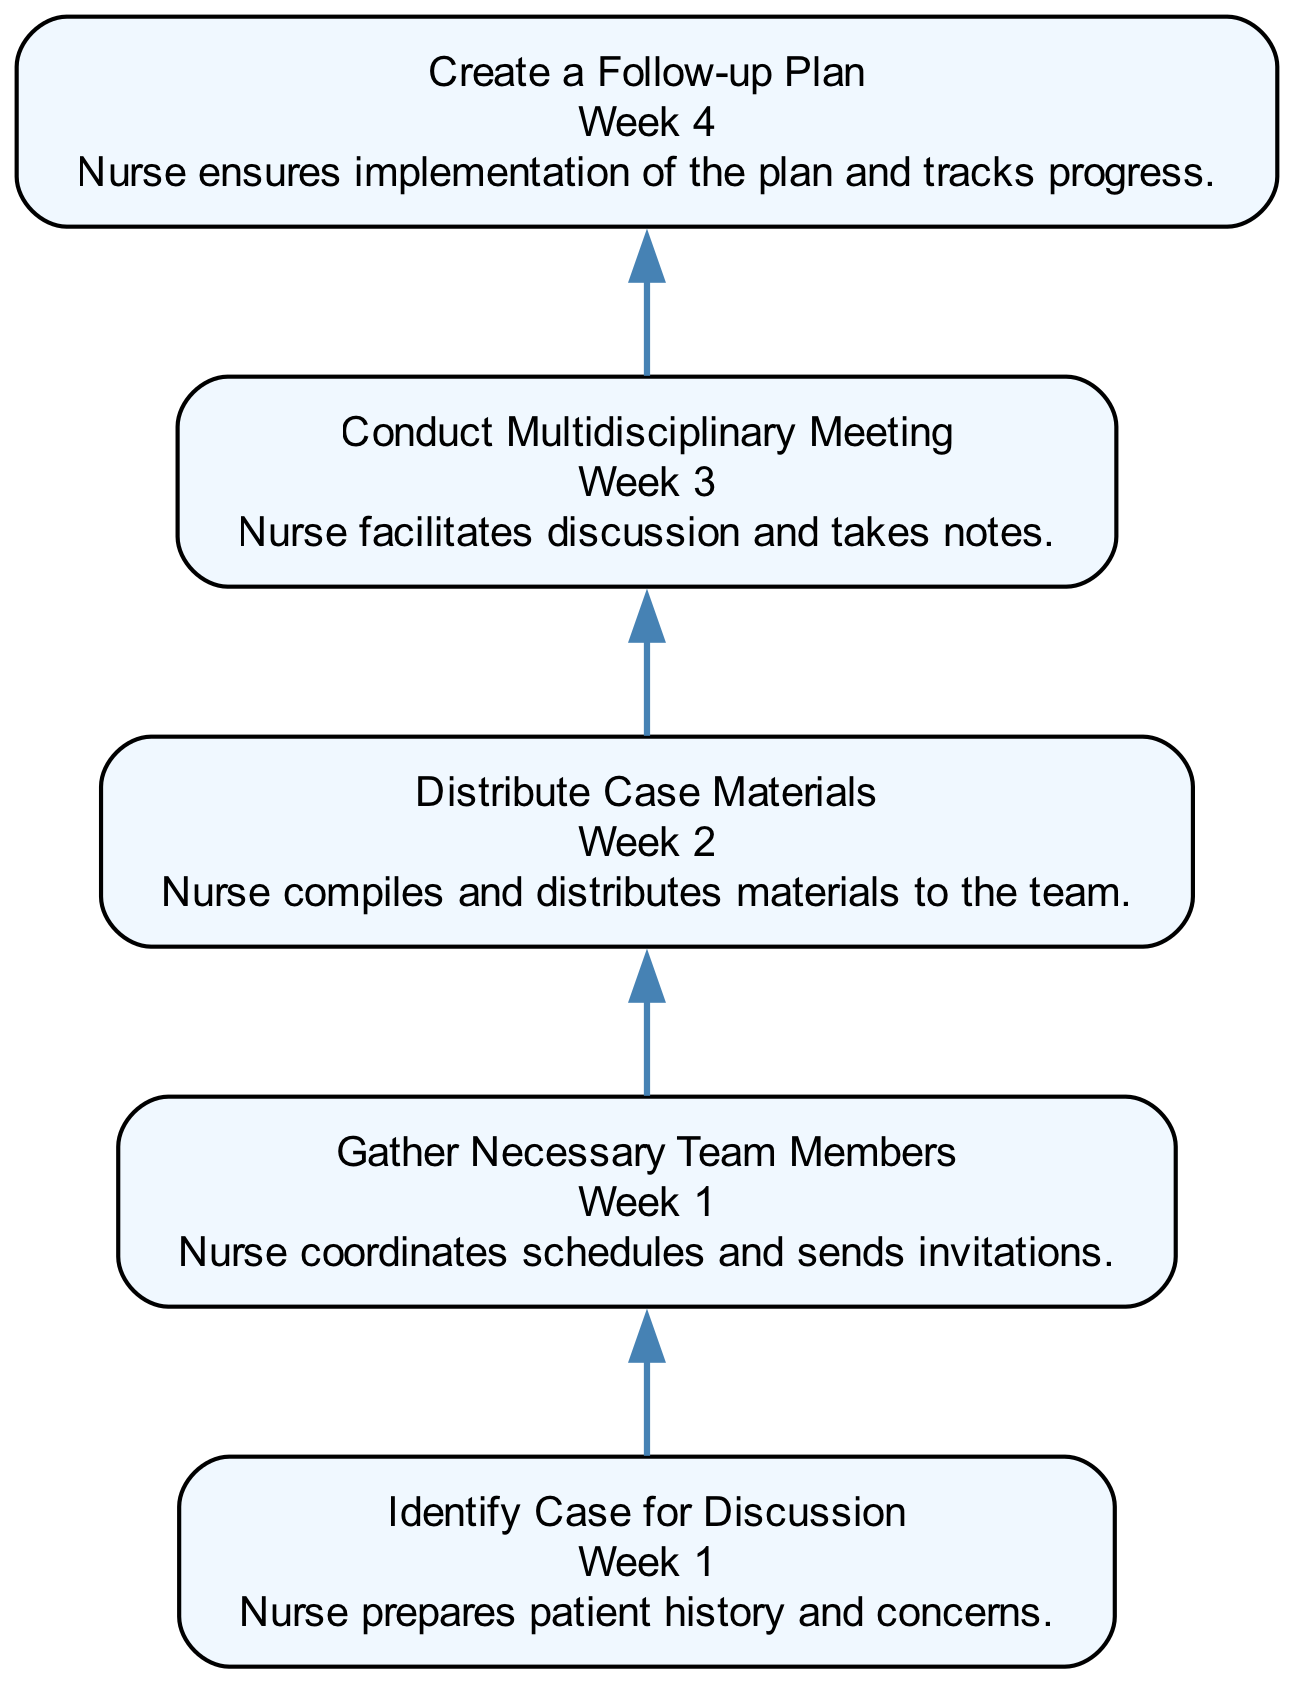What is the first step in the flow chart? The first step is to "Identify Case for Discussion," as this is the initial node in the flow chart sequence.
Answer: Identify Case for Discussion What is the timeline for distributing case materials? The second node in the diagram lists the timeline for distributing case materials as "Week 2."
Answer: Week 2 How many total steps are in the flow chart? By counting each of the distinct nodes in the flow chart, there are five total steps outlining the process.
Answer: 5 What participant contribution is made during the "Conduct Multidisciplinary Meeting"? According to the information in that specific node, the participant contribution listed is "Nurse facilitates discussion and takes notes."
Answer: Nurse facilitates discussion and takes notes Which step follows "Gather Necessary Team Members"? By following the directional flow from the second node, the step that immediately follows is "Distribute Case Materials."
Answer: Distribute Case Materials What is the timeline for creating a follow-up plan? The node for the follow-up plan states that the timeline for this step is "Week 4," indicating when this task should be executed.
Answer: Week 4 What is the last participant contribution mentioned in the diagram? The final participant contribution listed in the diagram corresponds to the last step, which is "Nurse ensures implementation of the plan and tracks progress."
Answer: Nurse ensures implementation of the plan and tracks progress What is the relationship between "Identify Case for Discussion" and "Conduct Multidisciplinary Meeting"? The first node leads directly to the fourth node, indicating that identifying a case is a prerequisite for conducting the meeting.
Answer: Identification leads to conducting What is the overall purpose of the diagram based on its steps? The steps in the flow chart collectively outline a structured approach to organizing multidisciplinary team meetings, thus providing a comprehensive care framework.
Answer: Organizing multidisciplinary team meetings 